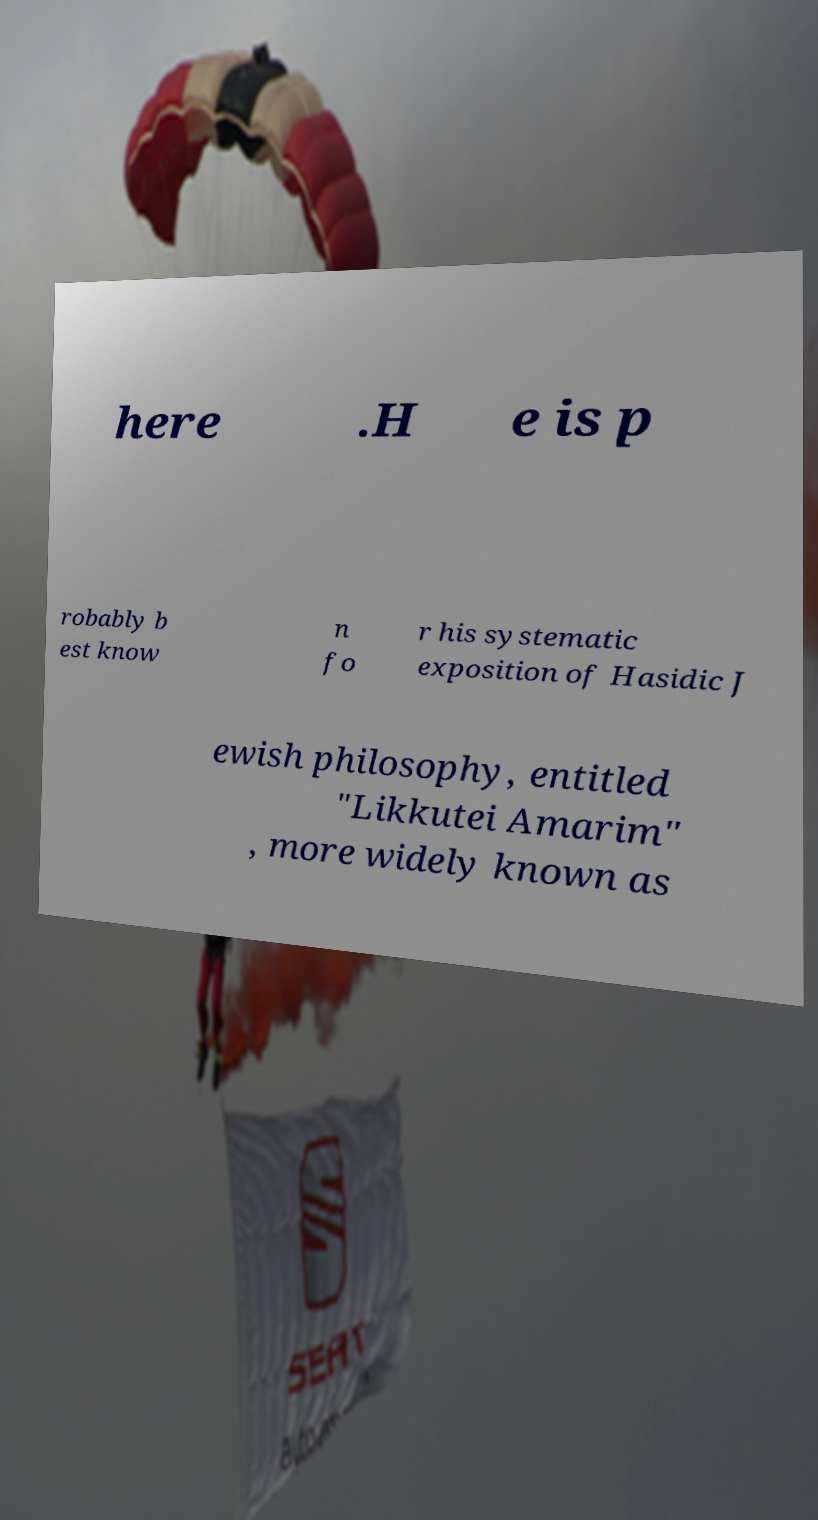What messages or text are displayed in this image? I need them in a readable, typed format. here .H e is p robably b est know n fo r his systematic exposition of Hasidic J ewish philosophy, entitled "Likkutei Amarim" , more widely known as 